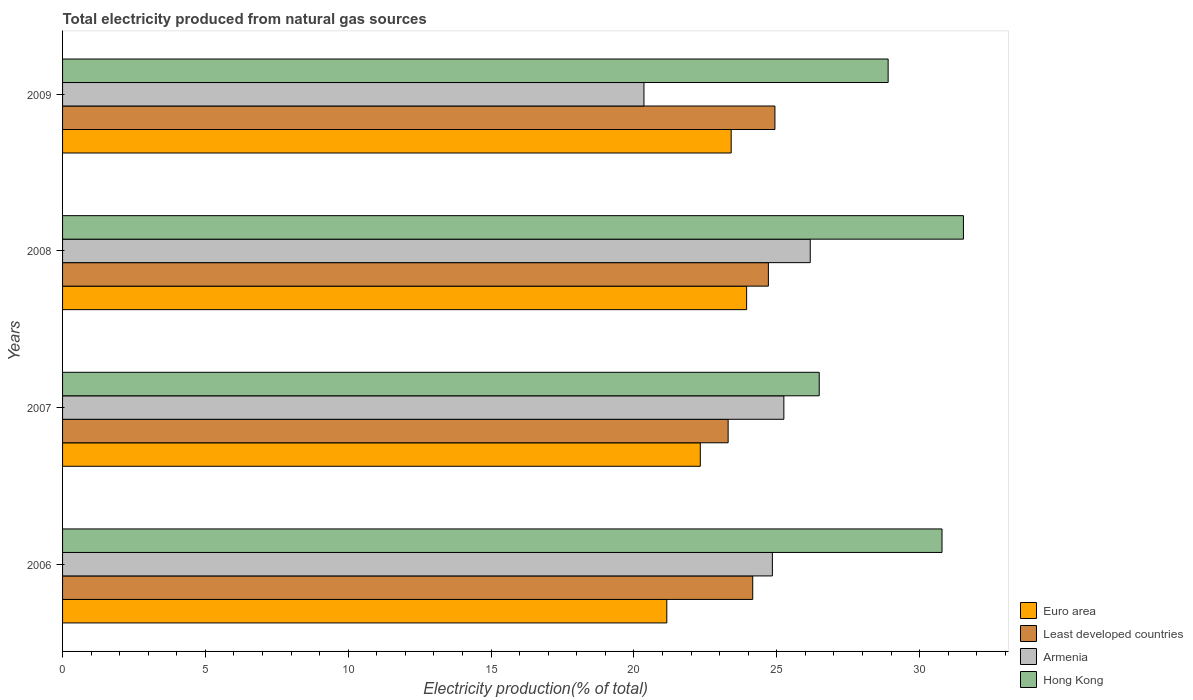How many groups of bars are there?
Offer a terse response. 4. How many bars are there on the 4th tick from the bottom?
Provide a short and direct response. 4. In how many cases, is the number of bars for a given year not equal to the number of legend labels?
Make the answer very short. 0. What is the total electricity produced in Armenia in 2008?
Give a very brief answer. 26.17. Across all years, what is the maximum total electricity produced in Euro area?
Make the answer very short. 23.94. Across all years, what is the minimum total electricity produced in Euro area?
Give a very brief answer. 21.15. In which year was the total electricity produced in Least developed countries maximum?
Keep it short and to the point. 2009. In which year was the total electricity produced in Armenia minimum?
Your answer should be very brief. 2009. What is the total total electricity produced in Hong Kong in the graph?
Provide a short and direct response. 117.69. What is the difference between the total electricity produced in Hong Kong in 2006 and that in 2009?
Give a very brief answer. 1.89. What is the difference between the total electricity produced in Euro area in 2008 and the total electricity produced in Armenia in 2007?
Provide a short and direct response. -1.3. What is the average total electricity produced in Hong Kong per year?
Offer a terse response. 29.42. In the year 2006, what is the difference between the total electricity produced in Armenia and total electricity produced in Hong Kong?
Offer a very short reply. -5.94. What is the ratio of the total electricity produced in Armenia in 2007 to that in 2009?
Offer a terse response. 1.24. What is the difference between the highest and the second highest total electricity produced in Least developed countries?
Ensure brevity in your answer.  0.23. What is the difference between the highest and the lowest total electricity produced in Euro area?
Provide a succinct answer. 2.79. In how many years, is the total electricity produced in Hong Kong greater than the average total electricity produced in Hong Kong taken over all years?
Your answer should be compact. 2. Is it the case that in every year, the sum of the total electricity produced in Hong Kong and total electricity produced in Armenia is greater than the sum of total electricity produced in Least developed countries and total electricity produced in Euro area?
Give a very brief answer. No. What does the 4th bar from the top in 2007 represents?
Your response must be concise. Euro area. What does the 3rd bar from the bottom in 2006 represents?
Your answer should be very brief. Armenia. How many bars are there?
Ensure brevity in your answer.  16. Are all the bars in the graph horizontal?
Your response must be concise. Yes. Does the graph contain grids?
Your answer should be compact. No. How many legend labels are there?
Make the answer very short. 4. What is the title of the graph?
Make the answer very short. Total electricity produced from natural gas sources. What is the label or title of the X-axis?
Your answer should be very brief. Electricity production(% of total). What is the label or title of the Y-axis?
Provide a succinct answer. Years. What is the Electricity production(% of total) of Euro area in 2006?
Give a very brief answer. 21.15. What is the Electricity production(% of total) of Least developed countries in 2006?
Your answer should be very brief. 24.16. What is the Electricity production(% of total) in Armenia in 2006?
Provide a succinct answer. 24.84. What is the Electricity production(% of total) of Hong Kong in 2006?
Offer a very short reply. 30.78. What is the Electricity production(% of total) of Euro area in 2007?
Your response must be concise. 22.32. What is the Electricity production(% of total) in Least developed countries in 2007?
Ensure brevity in your answer.  23.3. What is the Electricity production(% of total) of Armenia in 2007?
Provide a short and direct response. 25.25. What is the Electricity production(% of total) of Hong Kong in 2007?
Offer a very short reply. 26.48. What is the Electricity production(% of total) in Euro area in 2008?
Make the answer very short. 23.94. What is the Electricity production(% of total) in Least developed countries in 2008?
Offer a terse response. 24.7. What is the Electricity production(% of total) in Armenia in 2008?
Provide a short and direct response. 26.17. What is the Electricity production(% of total) in Hong Kong in 2008?
Keep it short and to the point. 31.53. What is the Electricity production(% of total) in Euro area in 2009?
Keep it short and to the point. 23.4. What is the Electricity production(% of total) of Least developed countries in 2009?
Your answer should be compact. 24.93. What is the Electricity production(% of total) in Armenia in 2009?
Keep it short and to the point. 20.35. What is the Electricity production(% of total) of Hong Kong in 2009?
Ensure brevity in your answer.  28.9. Across all years, what is the maximum Electricity production(% of total) of Euro area?
Provide a succinct answer. 23.94. Across all years, what is the maximum Electricity production(% of total) in Least developed countries?
Ensure brevity in your answer.  24.93. Across all years, what is the maximum Electricity production(% of total) in Armenia?
Give a very brief answer. 26.17. Across all years, what is the maximum Electricity production(% of total) in Hong Kong?
Offer a very short reply. 31.53. Across all years, what is the minimum Electricity production(% of total) of Euro area?
Keep it short and to the point. 21.15. Across all years, what is the minimum Electricity production(% of total) of Least developed countries?
Make the answer very short. 23.3. Across all years, what is the minimum Electricity production(% of total) of Armenia?
Give a very brief answer. 20.35. Across all years, what is the minimum Electricity production(% of total) in Hong Kong?
Keep it short and to the point. 26.48. What is the total Electricity production(% of total) of Euro area in the graph?
Provide a succinct answer. 90.82. What is the total Electricity production(% of total) of Least developed countries in the graph?
Offer a terse response. 97.09. What is the total Electricity production(% of total) of Armenia in the graph?
Provide a succinct answer. 96.61. What is the total Electricity production(% of total) of Hong Kong in the graph?
Keep it short and to the point. 117.69. What is the difference between the Electricity production(% of total) in Euro area in 2006 and that in 2007?
Your answer should be compact. -1.17. What is the difference between the Electricity production(% of total) of Least developed countries in 2006 and that in 2007?
Your response must be concise. 0.86. What is the difference between the Electricity production(% of total) in Armenia in 2006 and that in 2007?
Give a very brief answer. -0.4. What is the difference between the Electricity production(% of total) in Hong Kong in 2006 and that in 2007?
Offer a very short reply. 4.3. What is the difference between the Electricity production(% of total) in Euro area in 2006 and that in 2008?
Offer a terse response. -2.79. What is the difference between the Electricity production(% of total) in Least developed countries in 2006 and that in 2008?
Provide a short and direct response. -0.55. What is the difference between the Electricity production(% of total) in Armenia in 2006 and that in 2008?
Offer a terse response. -1.33. What is the difference between the Electricity production(% of total) in Hong Kong in 2006 and that in 2008?
Keep it short and to the point. -0.75. What is the difference between the Electricity production(% of total) of Euro area in 2006 and that in 2009?
Provide a short and direct response. -2.25. What is the difference between the Electricity production(% of total) in Least developed countries in 2006 and that in 2009?
Provide a short and direct response. -0.78. What is the difference between the Electricity production(% of total) of Armenia in 2006 and that in 2009?
Keep it short and to the point. 4.5. What is the difference between the Electricity production(% of total) in Hong Kong in 2006 and that in 2009?
Ensure brevity in your answer.  1.89. What is the difference between the Electricity production(% of total) in Euro area in 2007 and that in 2008?
Keep it short and to the point. -1.62. What is the difference between the Electricity production(% of total) of Least developed countries in 2007 and that in 2008?
Your answer should be very brief. -1.41. What is the difference between the Electricity production(% of total) in Armenia in 2007 and that in 2008?
Offer a very short reply. -0.92. What is the difference between the Electricity production(% of total) of Hong Kong in 2007 and that in 2008?
Provide a succinct answer. -5.05. What is the difference between the Electricity production(% of total) in Euro area in 2007 and that in 2009?
Provide a succinct answer. -1.08. What is the difference between the Electricity production(% of total) in Least developed countries in 2007 and that in 2009?
Ensure brevity in your answer.  -1.64. What is the difference between the Electricity production(% of total) in Armenia in 2007 and that in 2009?
Provide a short and direct response. 4.9. What is the difference between the Electricity production(% of total) in Hong Kong in 2007 and that in 2009?
Your answer should be very brief. -2.41. What is the difference between the Electricity production(% of total) in Euro area in 2008 and that in 2009?
Provide a short and direct response. 0.54. What is the difference between the Electricity production(% of total) of Least developed countries in 2008 and that in 2009?
Give a very brief answer. -0.23. What is the difference between the Electricity production(% of total) in Armenia in 2008 and that in 2009?
Ensure brevity in your answer.  5.82. What is the difference between the Electricity production(% of total) of Hong Kong in 2008 and that in 2009?
Your answer should be very brief. 2.64. What is the difference between the Electricity production(% of total) of Euro area in 2006 and the Electricity production(% of total) of Least developed countries in 2007?
Your answer should be compact. -2.15. What is the difference between the Electricity production(% of total) in Euro area in 2006 and the Electricity production(% of total) in Armenia in 2007?
Your answer should be compact. -4.1. What is the difference between the Electricity production(% of total) in Euro area in 2006 and the Electricity production(% of total) in Hong Kong in 2007?
Your response must be concise. -5.33. What is the difference between the Electricity production(% of total) in Least developed countries in 2006 and the Electricity production(% of total) in Armenia in 2007?
Keep it short and to the point. -1.09. What is the difference between the Electricity production(% of total) in Least developed countries in 2006 and the Electricity production(% of total) in Hong Kong in 2007?
Offer a very short reply. -2.33. What is the difference between the Electricity production(% of total) of Armenia in 2006 and the Electricity production(% of total) of Hong Kong in 2007?
Your answer should be compact. -1.64. What is the difference between the Electricity production(% of total) of Euro area in 2006 and the Electricity production(% of total) of Least developed countries in 2008?
Your response must be concise. -3.56. What is the difference between the Electricity production(% of total) of Euro area in 2006 and the Electricity production(% of total) of Armenia in 2008?
Your response must be concise. -5.02. What is the difference between the Electricity production(% of total) of Euro area in 2006 and the Electricity production(% of total) of Hong Kong in 2008?
Offer a terse response. -10.38. What is the difference between the Electricity production(% of total) in Least developed countries in 2006 and the Electricity production(% of total) in Armenia in 2008?
Offer a terse response. -2.01. What is the difference between the Electricity production(% of total) in Least developed countries in 2006 and the Electricity production(% of total) in Hong Kong in 2008?
Your answer should be very brief. -7.37. What is the difference between the Electricity production(% of total) in Armenia in 2006 and the Electricity production(% of total) in Hong Kong in 2008?
Offer a terse response. -6.69. What is the difference between the Electricity production(% of total) of Euro area in 2006 and the Electricity production(% of total) of Least developed countries in 2009?
Offer a terse response. -3.78. What is the difference between the Electricity production(% of total) in Euro area in 2006 and the Electricity production(% of total) in Armenia in 2009?
Provide a short and direct response. 0.8. What is the difference between the Electricity production(% of total) in Euro area in 2006 and the Electricity production(% of total) in Hong Kong in 2009?
Ensure brevity in your answer.  -7.75. What is the difference between the Electricity production(% of total) in Least developed countries in 2006 and the Electricity production(% of total) in Armenia in 2009?
Provide a succinct answer. 3.81. What is the difference between the Electricity production(% of total) in Least developed countries in 2006 and the Electricity production(% of total) in Hong Kong in 2009?
Provide a short and direct response. -4.74. What is the difference between the Electricity production(% of total) of Armenia in 2006 and the Electricity production(% of total) of Hong Kong in 2009?
Ensure brevity in your answer.  -4.05. What is the difference between the Electricity production(% of total) of Euro area in 2007 and the Electricity production(% of total) of Least developed countries in 2008?
Offer a terse response. -2.38. What is the difference between the Electricity production(% of total) of Euro area in 2007 and the Electricity production(% of total) of Armenia in 2008?
Make the answer very short. -3.85. What is the difference between the Electricity production(% of total) in Euro area in 2007 and the Electricity production(% of total) in Hong Kong in 2008?
Provide a short and direct response. -9.21. What is the difference between the Electricity production(% of total) of Least developed countries in 2007 and the Electricity production(% of total) of Armenia in 2008?
Your answer should be compact. -2.87. What is the difference between the Electricity production(% of total) of Least developed countries in 2007 and the Electricity production(% of total) of Hong Kong in 2008?
Make the answer very short. -8.24. What is the difference between the Electricity production(% of total) in Armenia in 2007 and the Electricity production(% of total) in Hong Kong in 2008?
Your answer should be compact. -6.29. What is the difference between the Electricity production(% of total) in Euro area in 2007 and the Electricity production(% of total) in Least developed countries in 2009?
Give a very brief answer. -2.61. What is the difference between the Electricity production(% of total) in Euro area in 2007 and the Electricity production(% of total) in Armenia in 2009?
Keep it short and to the point. 1.97. What is the difference between the Electricity production(% of total) in Euro area in 2007 and the Electricity production(% of total) in Hong Kong in 2009?
Keep it short and to the point. -6.58. What is the difference between the Electricity production(% of total) of Least developed countries in 2007 and the Electricity production(% of total) of Armenia in 2009?
Ensure brevity in your answer.  2.95. What is the difference between the Electricity production(% of total) in Least developed countries in 2007 and the Electricity production(% of total) in Hong Kong in 2009?
Give a very brief answer. -5.6. What is the difference between the Electricity production(% of total) in Armenia in 2007 and the Electricity production(% of total) in Hong Kong in 2009?
Offer a very short reply. -3.65. What is the difference between the Electricity production(% of total) of Euro area in 2008 and the Electricity production(% of total) of Least developed countries in 2009?
Your answer should be very brief. -0.99. What is the difference between the Electricity production(% of total) in Euro area in 2008 and the Electricity production(% of total) in Armenia in 2009?
Ensure brevity in your answer.  3.59. What is the difference between the Electricity production(% of total) of Euro area in 2008 and the Electricity production(% of total) of Hong Kong in 2009?
Give a very brief answer. -4.95. What is the difference between the Electricity production(% of total) of Least developed countries in 2008 and the Electricity production(% of total) of Armenia in 2009?
Your response must be concise. 4.36. What is the difference between the Electricity production(% of total) in Least developed countries in 2008 and the Electricity production(% of total) in Hong Kong in 2009?
Provide a short and direct response. -4.19. What is the difference between the Electricity production(% of total) of Armenia in 2008 and the Electricity production(% of total) of Hong Kong in 2009?
Keep it short and to the point. -2.73. What is the average Electricity production(% of total) in Euro area per year?
Offer a very short reply. 22.7. What is the average Electricity production(% of total) in Least developed countries per year?
Your answer should be compact. 24.27. What is the average Electricity production(% of total) in Armenia per year?
Your response must be concise. 24.15. What is the average Electricity production(% of total) in Hong Kong per year?
Make the answer very short. 29.42. In the year 2006, what is the difference between the Electricity production(% of total) in Euro area and Electricity production(% of total) in Least developed countries?
Offer a very short reply. -3.01. In the year 2006, what is the difference between the Electricity production(% of total) of Euro area and Electricity production(% of total) of Armenia?
Ensure brevity in your answer.  -3.69. In the year 2006, what is the difference between the Electricity production(% of total) in Euro area and Electricity production(% of total) in Hong Kong?
Give a very brief answer. -9.63. In the year 2006, what is the difference between the Electricity production(% of total) of Least developed countries and Electricity production(% of total) of Armenia?
Your answer should be compact. -0.69. In the year 2006, what is the difference between the Electricity production(% of total) in Least developed countries and Electricity production(% of total) in Hong Kong?
Provide a short and direct response. -6.62. In the year 2006, what is the difference between the Electricity production(% of total) in Armenia and Electricity production(% of total) in Hong Kong?
Your answer should be compact. -5.94. In the year 2007, what is the difference between the Electricity production(% of total) of Euro area and Electricity production(% of total) of Least developed countries?
Provide a succinct answer. -0.97. In the year 2007, what is the difference between the Electricity production(% of total) of Euro area and Electricity production(% of total) of Armenia?
Give a very brief answer. -2.92. In the year 2007, what is the difference between the Electricity production(% of total) of Euro area and Electricity production(% of total) of Hong Kong?
Give a very brief answer. -4.16. In the year 2007, what is the difference between the Electricity production(% of total) in Least developed countries and Electricity production(% of total) in Armenia?
Make the answer very short. -1.95. In the year 2007, what is the difference between the Electricity production(% of total) in Least developed countries and Electricity production(% of total) in Hong Kong?
Keep it short and to the point. -3.19. In the year 2007, what is the difference between the Electricity production(% of total) of Armenia and Electricity production(% of total) of Hong Kong?
Make the answer very short. -1.24. In the year 2008, what is the difference between the Electricity production(% of total) in Euro area and Electricity production(% of total) in Least developed countries?
Provide a short and direct response. -0.76. In the year 2008, what is the difference between the Electricity production(% of total) of Euro area and Electricity production(% of total) of Armenia?
Give a very brief answer. -2.23. In the year 2008, what is the difference between the Electricity production(% of total) in Euro area and Electricity production(% of total) in Hong Kong?
Provide a short and direct response. -7.59. In the year 2008, what is the difference between the Electricity production(% of total) in Least developed countries and Electricity production(% of total) in Armenia?
Your answer should be very brief. -1.47. In the year 2008, what is the difference between the Electricity production(% of total) of Least developed countries and Electricity production(% of total) of Hong Kong?
Provide a short and direct response. -6.83. In the year 2008, what is the difference between the Electricity production(% of total) in Armenia and Electricity production(% of total) in Hong Kong?
Your response must be concise. -5.36. In the year 2009, what is the difference between the Electricity production(% of total) of Euro area and Electricity production(% of total) of Least developed countries?
Give a very brief answer. -1.53. In the year 2009, what is the difference between the Electricity production(% of total) in Euro area and Electricity production(% of total) in Armenia?
Ensure brevity in your answer.  3.05. In the year 2009, what is the difference between the Electricity production(% of total) of Euro area and Electricity production(% of total) of Hong Kong?
Give a very brief answer. -5.49. In the year 2009, what is the difference between the Electricity production(% of total) in Least developed countries and Electricity production(% of total) in Armenia?
Make the answer very short. 4.58. In the year 2009, what is the difference between the Electricity production(% of total) of Least developed countries and Electricity production(% of total) of Hong Kong?
Make the answer very short. -3.96. In the year 2009, what is the difference between the Electricity production(% of total) in Armenia and Electricity production(% of total) in Hong Kong?
Give a very brief answer. -8.55. What is the ratio of the Electricity production(% of total) of Euro area in 2006 to that in 2007?
Offer a terse response. 0.95. What is the ratio of the Electricity production(% of total) of Least developed countries in 2006 to that in 2007?
Keep it short and to the point. 1.04. What is the ratio of the Electricity production(% of total) in Armenia in 2006 to that in 2007?
Ensure brevity in your answer.  0.98. What is the ratio of the Electricity production(% of total) of Hong Kong in 2006 to that in 2007?
Give a very brief answer. 1.16. What is the ratio of the Electricity production(% of total) in Euro area in 2006 to that in 2008?
Ensure brevity in your answer.  0.88. What is the ratio of the Electricity production(% of total) in Least developed countries in 2006 to that in 2008?
Give a very brief answer. 0.98. What is the ratio of the Electricity production(% of total) in Armenia in 2006 to that in 2008?
Keep it short and to the point. 0.95. What is the ratio of the Electricity production(% of total) of Hong Kong in 2006 to that in 2008?
Provide a succinct answer. 0.98. What is the ratio of the Electricity production(% of total) of Euro area in 2006 to that in 2009?
Make the answer very short. 0.9. What is the ratio of the Electricity production(% of total) of Least developed countries in 2006 to that in 2009?
Your answer should be very brief. 0.97. What is the ratio of the Electricity production(% of total) in Armenia in 2006 to that in 2009?
Offer a terse response. 1.22. What is the ratio of the Electricity production(% of total) of Hong Kong in 2006 to that in 2009?
Keep it short and to the point. 1.07. What is the ratio of the Electricity production(% of total) of Euro area in 2007 to that in 2008?
Ensure brevity in your answer.  0.93. What is the ratio of the Electricity production(% of total) of Least developed countries in 2007 to that in 2008?
Ensure brevity in your answer.  0.94. What is the ratio of the Electricity production(% of total) in Armenia in 2007 to that in 2008?
Your answer should be compact. 0.96. What is the ratio of the Electricity production(% of total) of Hong Kong in 2007 to that in 2008?
Your response must be concise. 0.84. What is the ratio of the Electricity production(% of total) in Euro area in 2007 to that in 2009?
Provide a short and direct response. 0.95. What is the ratio of the Electricity production(% of total) in Least developed countries in 2007 to that in 2009?
Your answer should be very brief. 0.93. What is the ratio of the Electricity production(% of total) of Armenia in 2007 to that in 2009?
Your response must be concise. 1.24. What is the ratio of the Electricity production(% of total) in Hong Kong in 2007 to that in 2009?
Your response must be concise. 0.92. What is the ratio of the Electricity production(% of total) in Euro area in 2008 to that in 2009?
Your answer should be very brief. 1.02. What is the ratio of the Electricity production(% of total) of Armenia in 2008 to that in 2009?
Give a very brief answer. 1.29. What is the ratio of the Electricity production(% of total) in Hong Kong in 2008 to that in 2009?
Provide a short and direct response. 1.09. What is the difference between the highest and the second highest Electricity production(% of total) in Euro area?
Offer a very short reply. 0.54. What is the difference between the highest and the second highest Electricity production(% of total) of Least developed countries?
Make the answer very short. 0.23. What is the difference between the highest and the second highest Electricity production(% of total) of Armenia?
Ensure brevity in your answer.  0.92. What is the difference between the highest and the second highest Electricity production(% of total) of Hong Kong?
Make the answer very short. 0.75. What is the difference between the highest and the lowest Electricity production(% of total) in Euro area?
Keep it short and to the point. 2.79. What is the difference between the highest and the lowest Electricity production(% of total) in Least developed countries?
Your answer should be very brief. 1.64. What is the difference between the highest and the lowest Electricity production(% of total) of Armenia?
Give a very brief answer. 5.82. What is the difference between the highest and the lowest Electricity production(% of total) of Hong Kong?
Offer a very short reply. 5.05. 